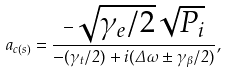Convert formula to latex. <formula><loc_0><loc_0><loc_500><loc_500>a _ { c ( s ) } = \frac { - \sqrt { \gamma _ { e } / 2 } \sqrt { P _ { i } } } { - ( \gamma _ { t } / 2 ) + i ( \Delta \omega \pm \gamma _ { \beta } / 2 ) } ,</formula> 